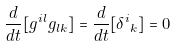<formula> <loc_0><loc_0><loc_500><loc_500>\frac { d } { d t } [ g ^ { i l } g _ { l k } ] = \frac { d } { d t } [ { { \delta } ^ { i } } _ { k } ] = 0</formula> 